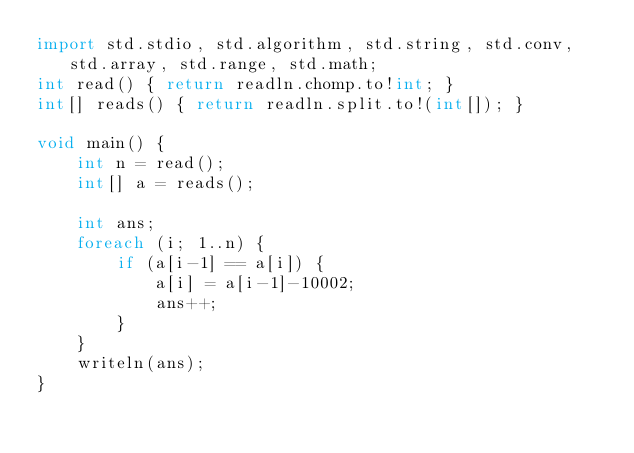<code> <loc_0><loc_0><loc_500><loc_500><_D_>import std.stdio, std.algorithm, std.string, std.conv, std.array, std.range, std.math;
int read() { return readln.chomp.to!int; }
int[] reads() { return readln.split.to!(int[]); }

void main() {
    int n = read();
    int[] a = reads();

    int ans;
    foreach (i; 1..n) {
        if (a[i-1] == a[i]) {
            a[i] = a[i-1]-10002;
            ans++;
        }
    }
    writeln(ans);
}</code> 